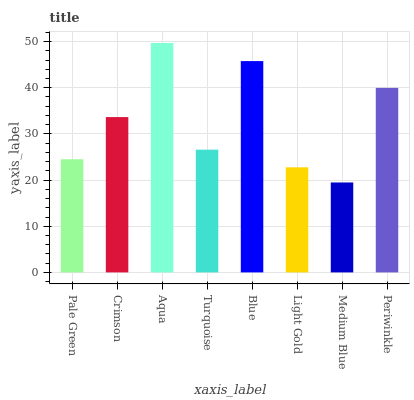Is Medium Blue the minimum?
Answer yes or no. Yes. Is Aqua the maximum?
Answer yes or no. Yes. Is Crimson the minimum?
Answer yes or no. No. Is Crimson the maximum?
Answer yes or no. No. Is Crimson greater than Pale Green?
Answer yes or no. Yes. Is Pale Green less than Crimson?
Answer yes or no. Yes. Is Pale Green greater than Crimson?
Answer yes or no. No. Is Crimson less than Pale Green?
Answer yes or no. No. Is Crimson the high median?
Answer yes or no. Yes. Is Turquoise the low median?
Answer yes or no. Yes. Is Aqua the high median?
Answer yes or no. No. Is Crimson the low median?
Answer yes or no. No. 